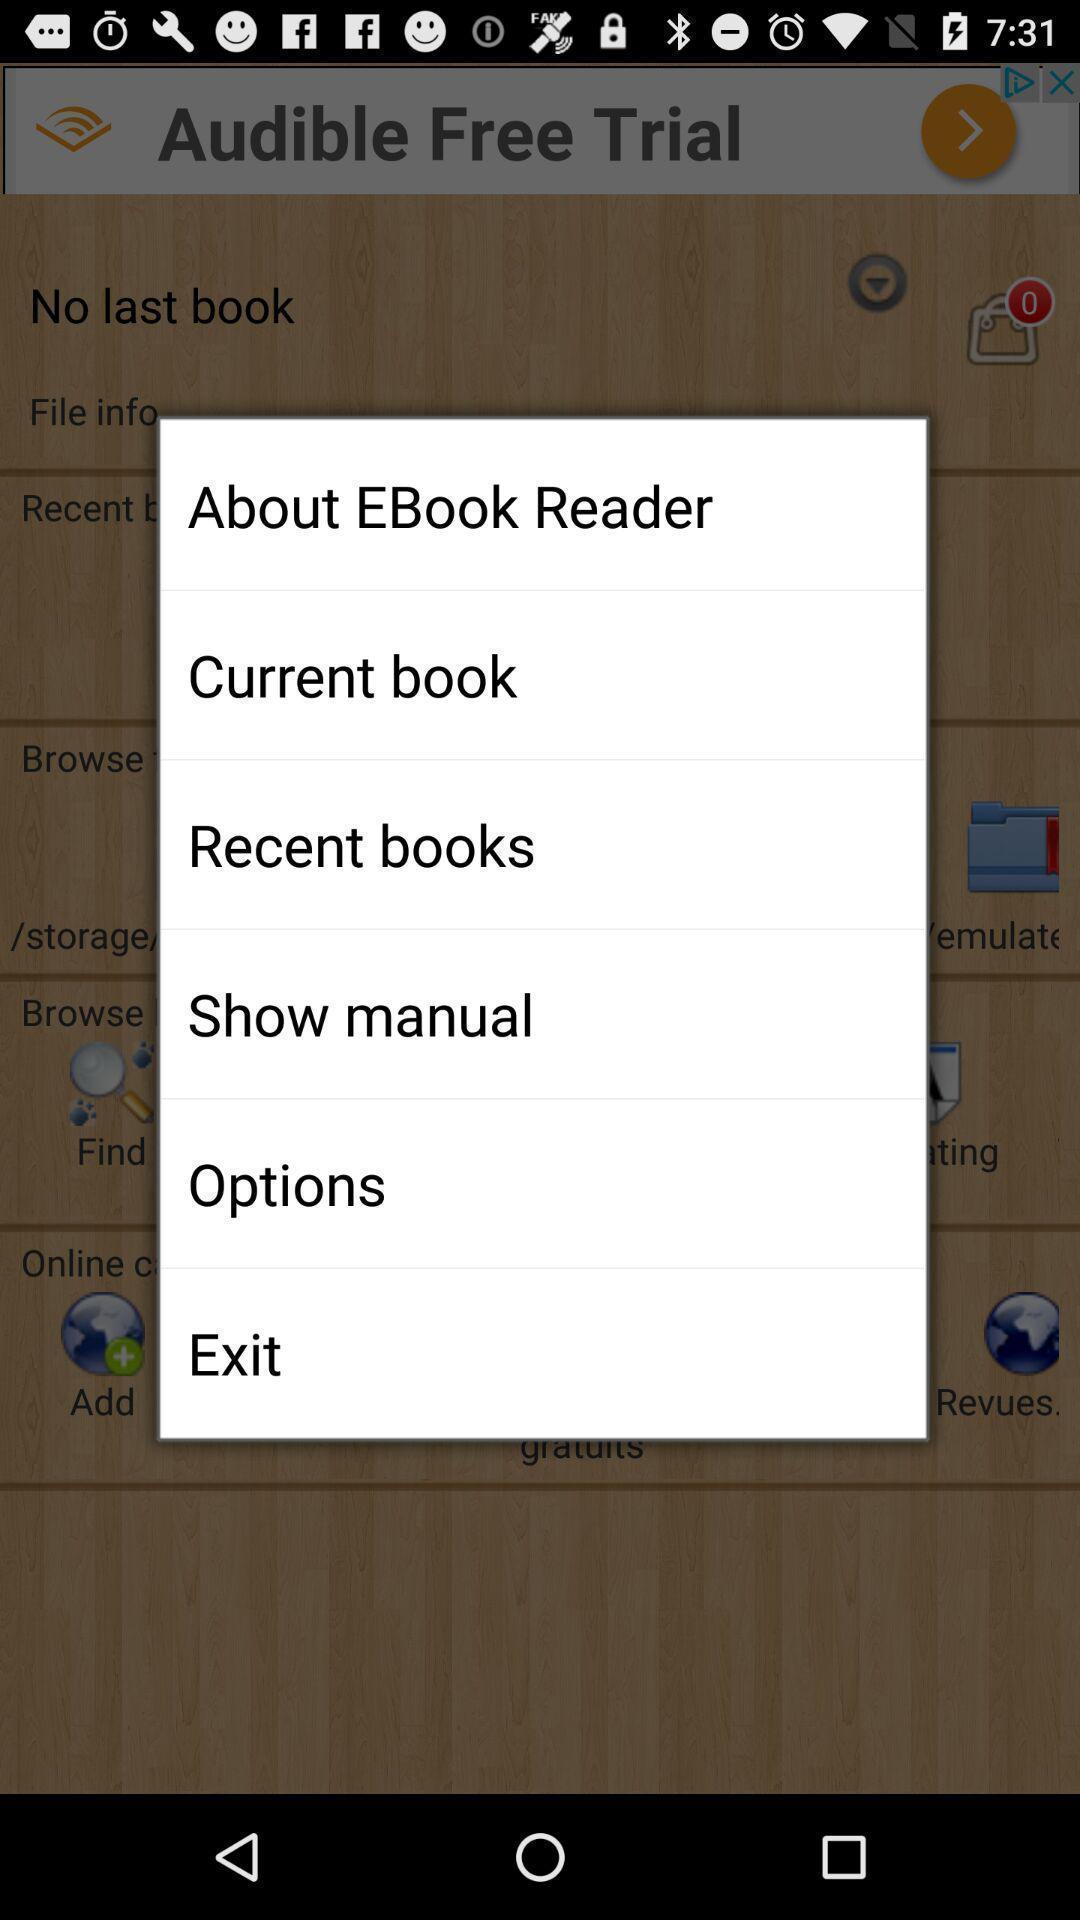What details can you identify in this image? Popup displaying list of information about an ebook reading application. 